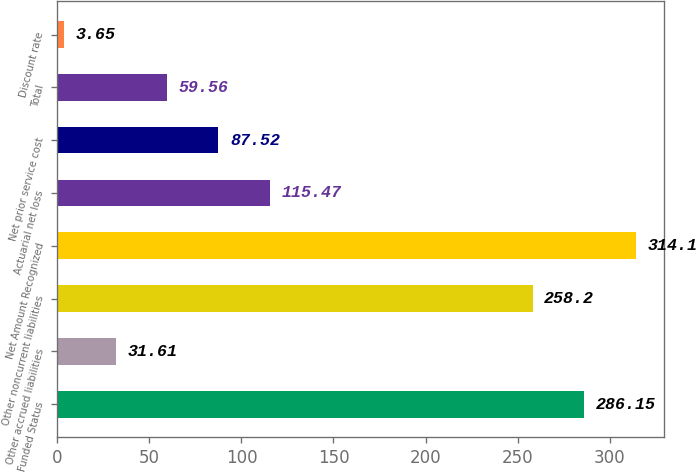Convert chart to OTSL. <chart><loc_0><loc_0><loc_500><loc_500><bar_chart><fcel>Funded Status<fcel>Other accrued liabilities<fcel>Other noncurrent liabilities<fcel>Net Amount Recognized<fcel>Actuarial net loss<fcel>Net prior service cost<fcel>Total<fcel>Discount rate<nl><fcel>286.15<fcel>31.61<fcel>258.2<fcel>314.1<fcel>115.47<fcel>87.52<fcel>59.56<fcel>3.65<nl></chart> 